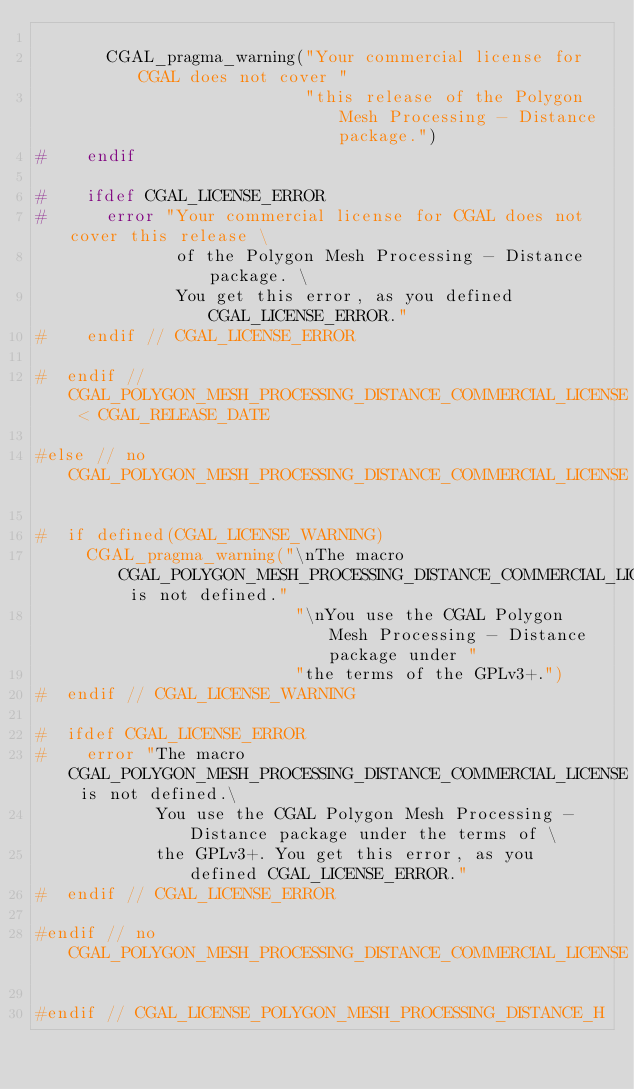Convert code to text. <code><loc_0><loc_0><loc_500><loc_500><_C_>
       CGAL_pragma_warning("Your commercial license for CGAL does not cover "
                           "this release of the Polygon Mesh Processing - Distance package.")
#    endif

#    ifdef CGAL_LICENSE_ERROR
#      error "Your commercial license for CGAL does not cover this release \
              of the Polygon Mesh Processing - Distance package. \
              You get this error, as you defined CGAL_LICENSE_ERROR."
#    endif // CGAL_LICENSE_ERROR

#  endif // CGAL_POLYGON_MESH_PROCESSING_DISTANCE_COMMERCIAL_LICENSE < CGAL_RELEASE_DATE

#else // no CGAL_POLYGON_MESH_PROCESSING_DISTANCE_COMMERCIAL_LICENSE

#  if defined(CGAL_LICENSE_WARNING)
     CGAL_pragma_warning("\nThe macro CGAL_POLYGON_MESH_PROCESSING_DISTANCE_COMMERCIAL_LICENSE is not defined."
                          "\nYou use the CGAL Polygon Mesh Processing - Distance package under "
                          "the terms of the GPLv3+.")
#  endif // CGAL_LICENSE_WARNING

#  ifdef CGAL_LICENSE_ERROR
#    error "The macro CGAL_POLYGON_MESH_PROCESSING_DISTANCE_COMMERCIAL_LICENSE is not defined.\
            You use the CGAL Polygon Mesh Processing - Distance package under the terms of \
            the GPLv3+. You get this error, as you defined CGAL_LICENSE_ERROR."
#  endif // CGAL_LICENSE_ERROR

#endif // no CGAL_POLYGON_MESH_PROCESSING_DISTANCE_COMMERCIAL_LICENSE

#endif // CGAL_LICENSE_POLYGON_MESH_PROCESSING_DISTANCE_H
</code> 